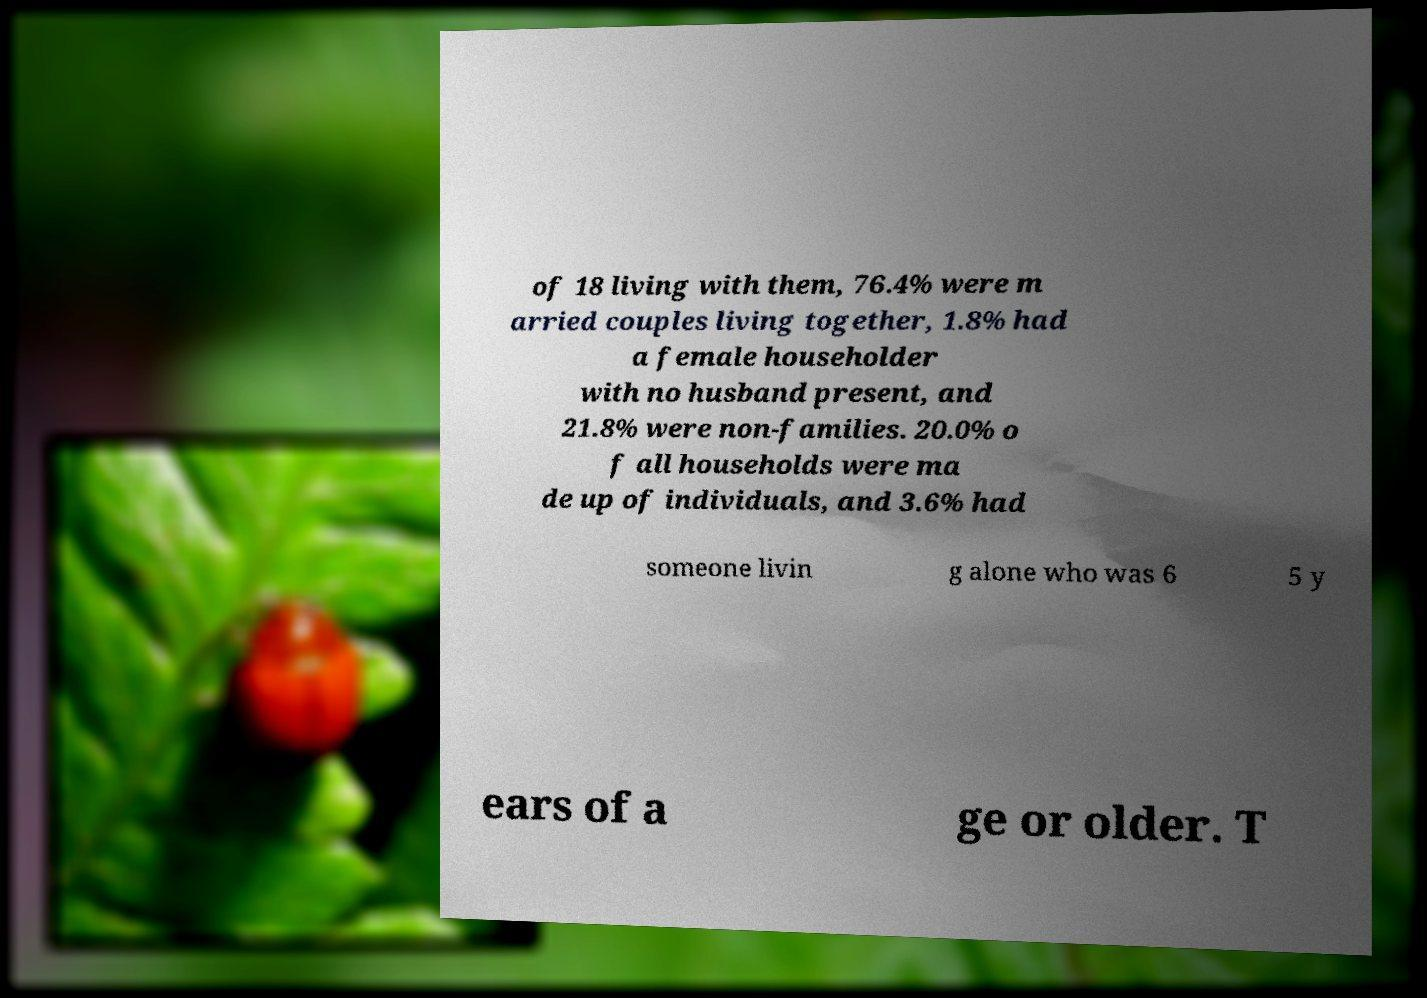What messages or text are displayed in this image? I need them in a readable, typed format. of 18 living with them, 76.4% were m arried couples living together, 1.8% had a female householder with no husband present, and 21.8% were non-families. 20.0% o f all households were ma de up of individuals, and 3.6% had someone livin g alone who was 6 5 y ears of a ge or older. T 